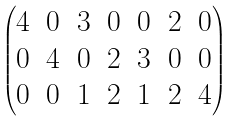<formula> <loc_0><loc_0><loc_500><loc_500>\begin{pmatrix} 4 & 0 & 3 & 0 & 0 & 2 & 0 \\ 0 & 4 & 0 & 2 & 3 & 0 & 0 \\ 0 & 0 & 1 & 2 & 1 & 2 & 4 \end{pmatrix}</formula> 